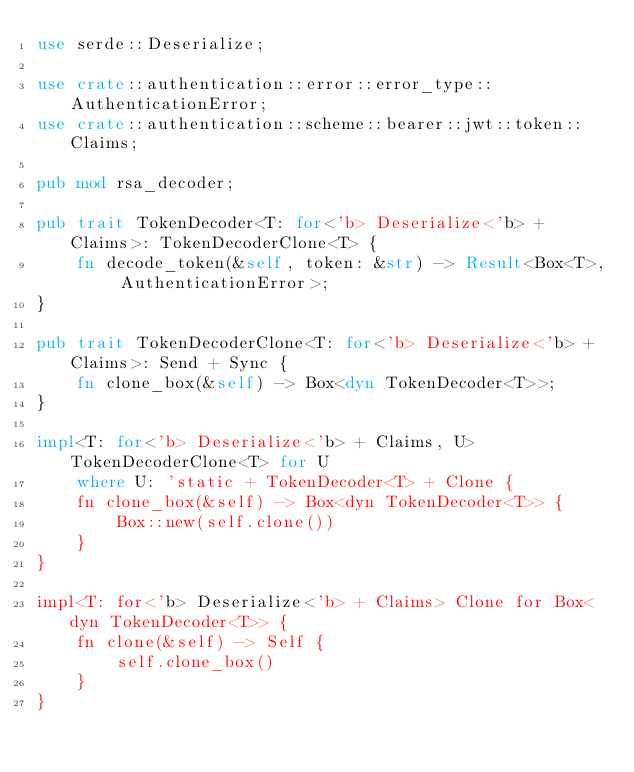Convert code to text. <code><loc_0><loc_0><loc_500><loc_500><_Rust_>use serde::Deserialize;

use crate::authentication::error::error_type::AuthenticationError;
use crate::authentication::scheme::bearer::jwt::token::Claims;

pub mod rsa_decoder;

pub trait TokenDecoder<T: for<'b> Deserialize<'b> + Claims>: TokenDecoderClone<T> {
    fn decode_token(&self, token: &str) -> Result<Box<T>, AuthenticationError>;
}

pub trait TokenDecoderClone<T: for<'b> Deserialize<'b> + Claims>: Send + Sync {
    fn clone_box(&self) -> Box<dyn TokenDecoder<T>>;
}

impl<T: for<'b> Deserialize<'b> + Claims, U> TokenDecoderClone<T> for U
    where U: 'static + TokenDecoder<T> + Clone {
    fn clone_box(&self) -> Box<dyn TokenDecoder<T>> {
        Box::new(self.clone())
    }
}

impl<T: for<'b> Deserialize<'b> + Claims> Clone for Box<dyn TokenDecoder<T>> {
    fn clone(&self) -> Self {
        self.clone_box()
    }
}</code> 